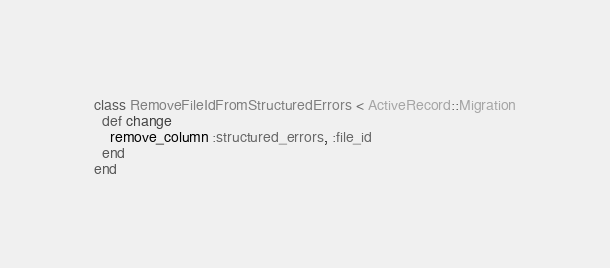Convert code to text. <code><loc_0><loc_0><loc_500><loc_500><_Ruby_>class RemoveFileIdFromStructuredErrors < ActiveRecord::Migration
  def change
    remove_column :structured_errors, :file_id
  end
end
</code> 